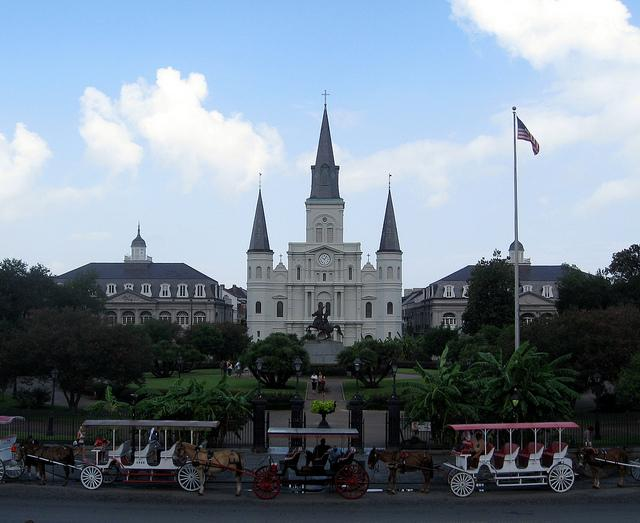What period of the day is it in the photo? Please explain your reasoning. late morning. The sun is just rising, and it is probably almost noon. 